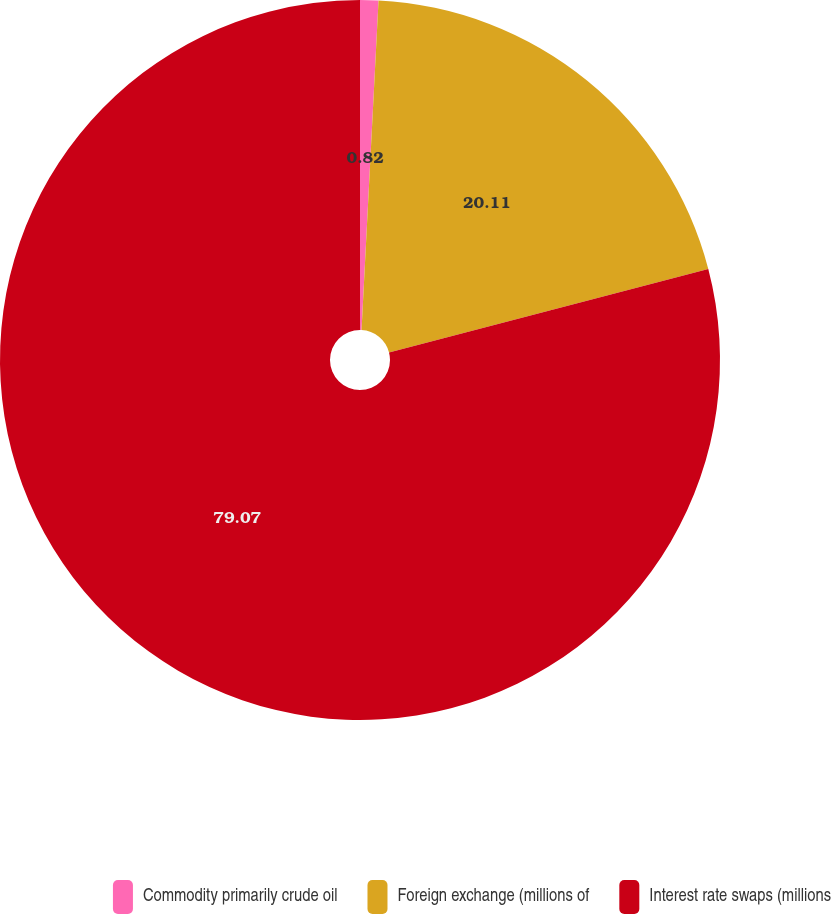Convert chart. <chart><loc_0><loc_0><loc_500><loc_500><pie_chart><fcel>Commodity primarily crude oil<fcel>Foreign exchange (millions of<fcel>Interest rate swaps (millions<nl><fcel>0.82%<fcel>20.11%<fcel>79.07%<nl></chart> 